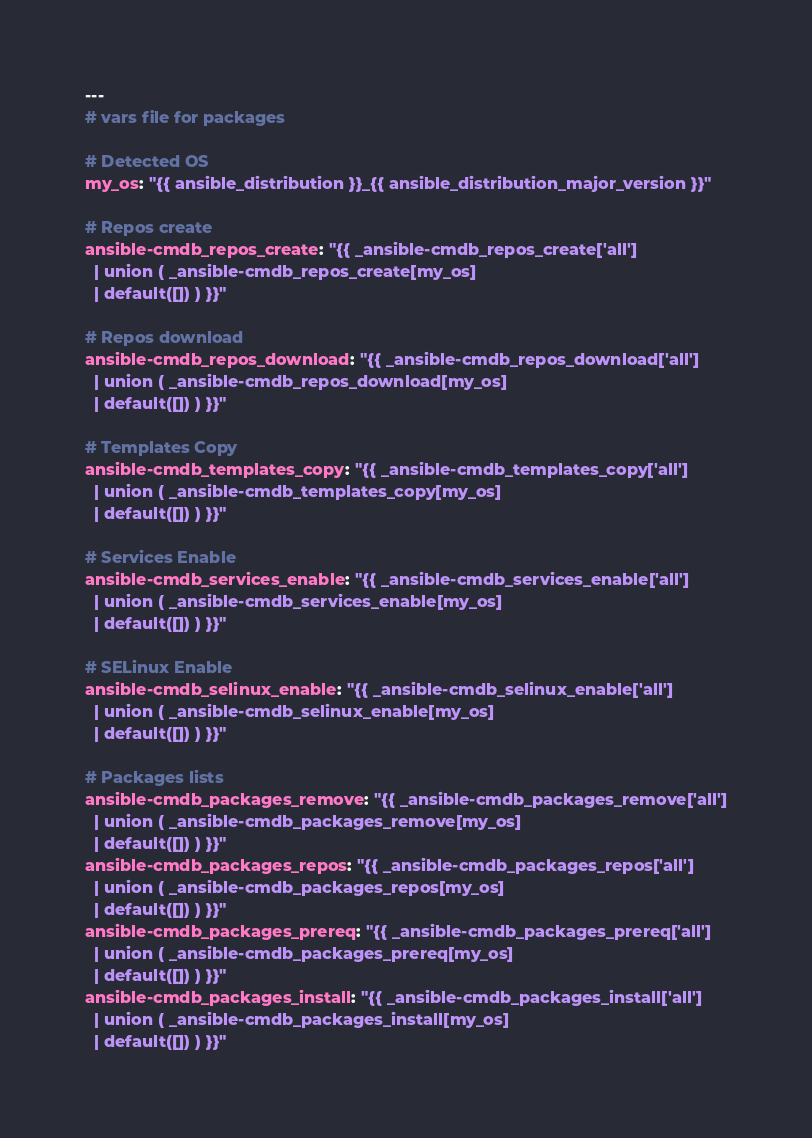Convert code to text. <code><loc_0><loc_0><loc_500><loc_500><_YAML_>---
# vars file for packages

# Detected OS
my_os: "{{ ansible_distribution }}_{{ ansible_distribution_major_version }}"

# Repos create
ansible-cmdb_repos_create: "{{ _ansible-cmdb_repos_create['all']
  | union ( _ansible-cmdb_repos_create[my_os]
  | default([]) ) }}"

# Repos download
ansible-cmdb_repos_download: "{{ _ansible-cmdb_repos_download['all']
  | union ( _ansible-cmdb_repos_download[my_os]
  | default([]) ) }}"

# Templates Copy
ansible-cmdb_templates_copy: "{{ _ansible-cmdb_templates_copy['all']
  | union ( _ansible-cmdb_templates_copy[my_os]
  | default([]) ) }}"

# Services Enable
ansible-cmdb_services_enable: "{{ _ansible-cmdb_services_enable['all']
  | union ( _ansible-cmdb_services_enable[my_os]
  | default([]) ) }}"

# SELinux Enable
ansible-cmdb_selinux_enable: "{{ _ansible-cmdb_selinux_enable['all']
  | union ( _ansible-cmdb_selinux_enable[my_os]
  | default([]) ) }}"

# Packages lists
ansible-cmdb_packages_remove: "{{ _ansible-cmdb_packages_remove['all']
  | union ( _ansible-cmdb_packages_remove[my_os]
  | default([]) ) }}"
ansible-cmdb_packages_repos: "{{ _ansible-cmdb_packages_repos['all']
  | union ( _ansible-cmdb_packages_repos[my_os]
  | default([]) ) }}"
ansible-cmdb_packages_prereq: "{{ _ansible-cmdb_packages_prereq['all']
  | union ( _ansible-cmdb_packages_prereq[my_os]
  | default([]) ) }}"
ansible-cmdb_packages_install: "{{ _ansible-cmdb_packages_install['all']
  | union ( _ansible-cmdb_packages_install[my_os]
  | default([]) ) }}"
</code> 